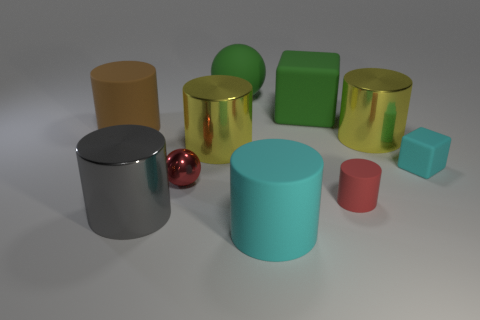Subtract all small red cylinders. How many cylinders are left? 5 Subtract all green blocks. How many blocks are left? 1 Subtract 1 red balls. How many objects are left? 9 Subtract all balls. How many objects are left? 8 Subtract 4 cylinders. How many cylinders are left? 2 Subtract all blue cylinders. Subtract all cyan balls. How many cylinders are left? 6 Subtract all brown cylinders. How many green spheres are left? 1 Subtract all brown rubber cylinders. Subtract all red shiny balls. How many objects are left? 8 Add 2 tiny cyan matte cubes. How many tiny cyan matte cubes are left? 3 Add 4 big cyan objects. How many big cyan objects exist? 5 